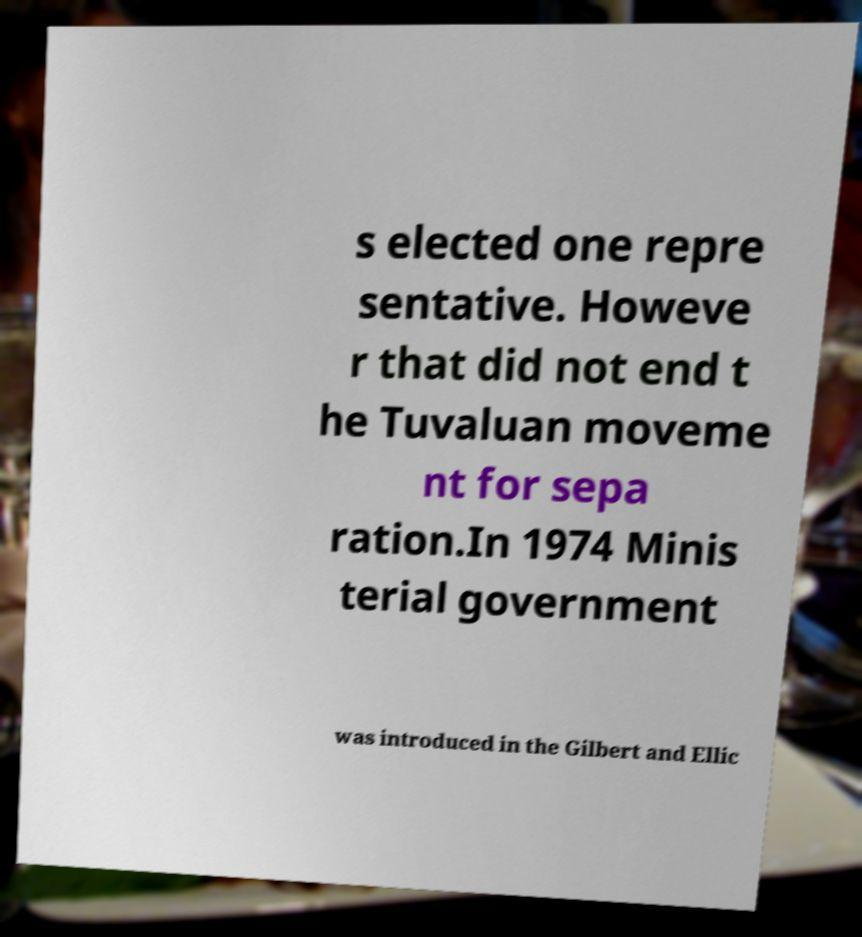Please read and relay the text visible in this image. What does it say? s elected one repre sentative. Howeve r that did not end t he Tuvaluan moveme nt for sepa ration.In 1974 Minis terial government was introduced in the Gilbert and Ellic 